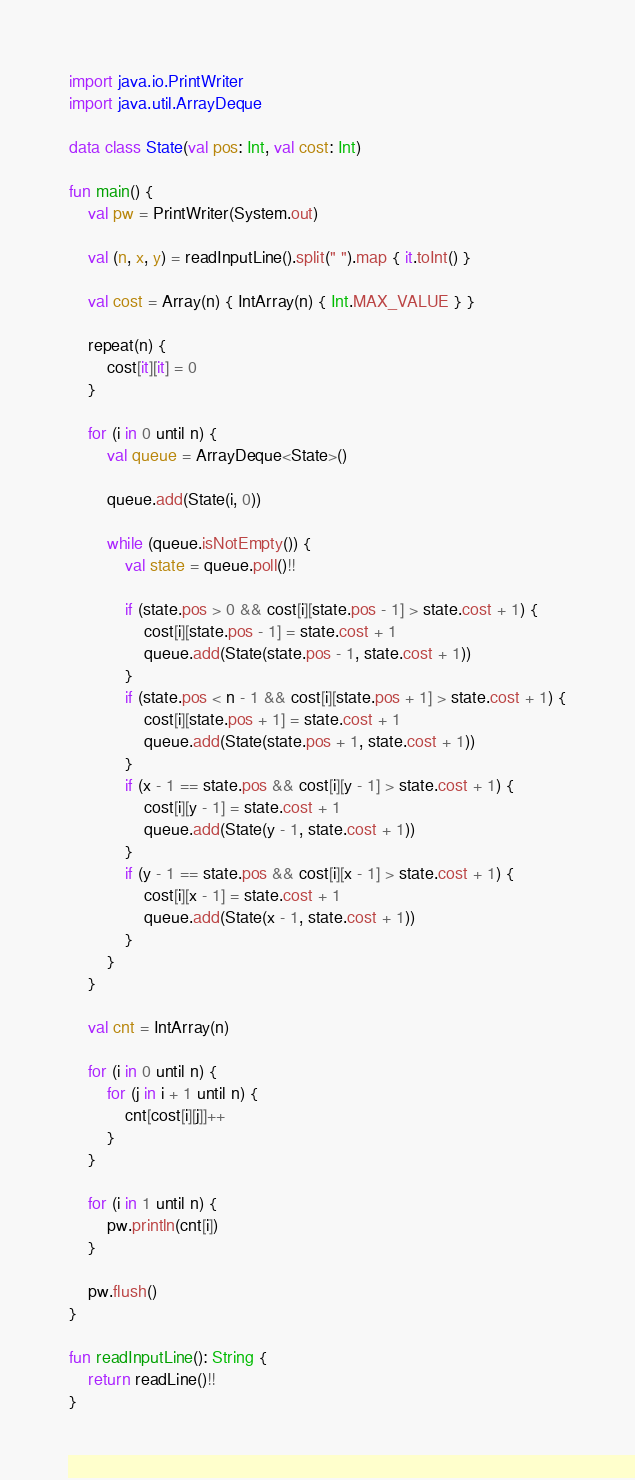<code> <loc_0><loc_0><loc_500><loc_500><_Kotlin_>import java.io.PrintWriter
import java.util.ArrayDeque

data class State(val pos: Int, val cost: Int)

fun main() {
    val pw = PrintWriter(System.out)

    val (n, x, y) = readInputLine().split(" ").map { it.toInt() }

    val cost = Array(n) { IntArray(n) { Int.MAX_VALUE } }

    repeat(n) {
        cost[it][it] = 0
    }

    for (i in 0 until n) {
        val queue = ArrayDeque<State>()

        queue.add(State(i, 0))

        while (queue.isNotEmpty()) {
            val state = queue.poll()!!

            if (state.pos > 0 && cost[i][state.pos - 1] > state.cost + 1) {
                cost[i][state.pos - 1] = state.cost + 1
                queue.add(State(state.pos - 1, state.cost + 1))
            }
            if (state.pos < n - 1 && cost[i][state.pos + 1] > state.cost + 1) {
                cost[i][state.pos + 1] = state.cost + 1
                queue.add(State(state.pos + 1, state.cost + 1))
            }
            if (x - 1 == state.pos && cost[i][y - 1] > state.cost + 1) {
                cost[i][y - 1] = state.cost + 1
                queue.add(State(y - 1, state.cost + 1))
            }
            if (y - 1 == state.pos && cost[i][x - 1] > state.cost + 1) {
                cost[i][x - 1] = state.cost + 1
                queue.add(State(x - 1, state.cost + 1))
            }
        }
    }

    val cnt = IntArray(n)

    for (i in 0 until n) {
        for (j in i + 1 until n) {
            cnt[cost[i][j]]++
        }
    }

    for (i in 1 until n) {
        pw.println(cnt[i])
    }

    pw.flush()
}

fun readInputLine(): String {
    return readLine()!!
}
</code> 